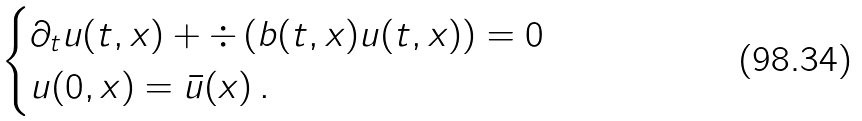Convert formula to latex. <formula><loc_0><loc_0><loc_500><loc_500>\begin{cases} \partial _ { t } u ( t , x ) + \div \left ( b ( t , x ) u ( t , x ) \right ) = 0 \\ u ( 0 , x ) = \bar { u } ( x ) \, . \end{cases}</formula> 